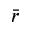Convert formula to latex. <formula><loc_0><loc_0><loc_500><loc_500>\bar { r }</formula> 